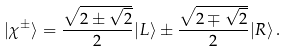<formula> <loc_0><loc_0><loc_500><loc_500>| \chi ^ { \pm } \rangle = \frac { \sqrt { 2 \pm \sqrt { 2 } } } { 2 } | L \rangle \pm \frac { \sqrt { 2 \mp \sqrt { 2 } } } { 2 } | R \rangle \, .</formula> 